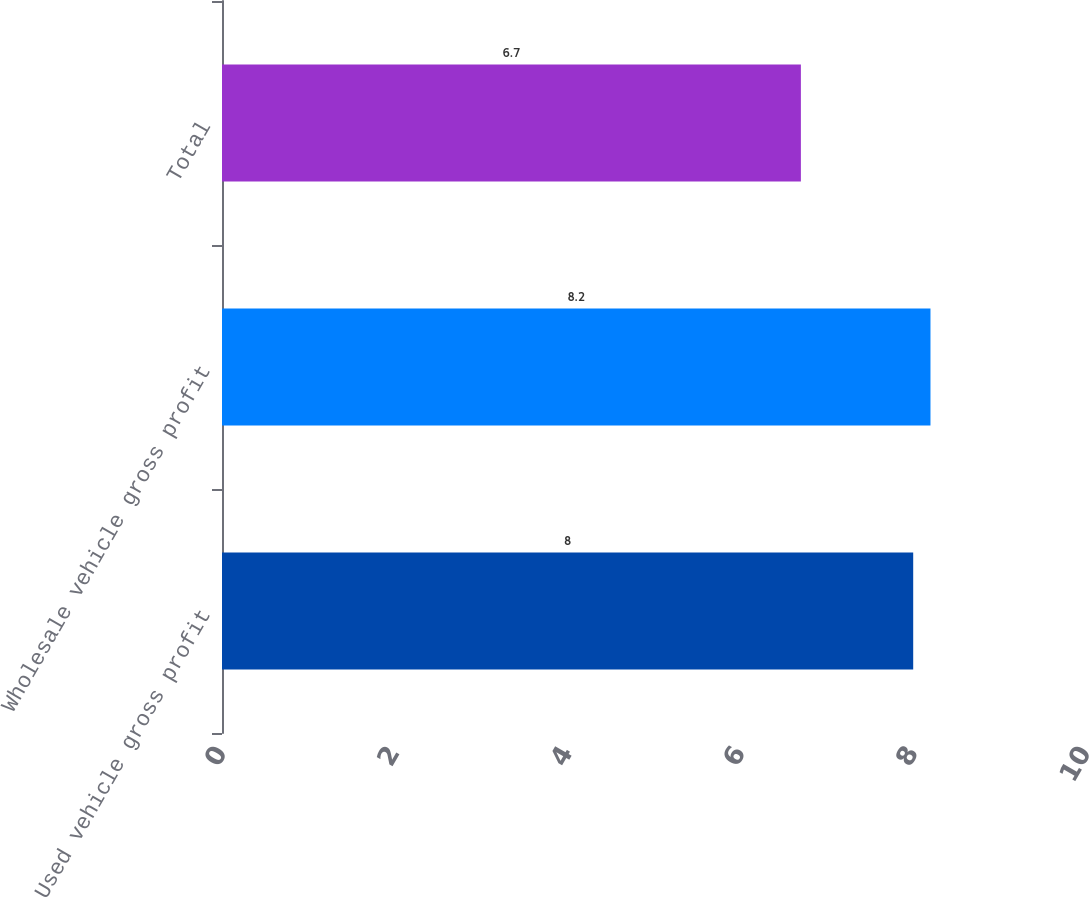Convert chart to OTSL. <chart><loc_0><loc_0><loc_500><loc_500><bar_chart><fcel>Used vehicle gross profit<fcel>Wholesale vehicle gross profit<fcel>Total<nl><fcel>8<fcel>8.2<fcel>6.7<nl></chart> 